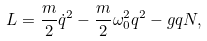<formula> <loc_0><loc_0><loc_500><loc_500>L = \frac { m } { 2 } \dot { q } ^ { 2 } - \frac { m } { 2 } \omega _ { 0 } ^ { 2 } q ^ { 2 } - g q N ,</formula> 